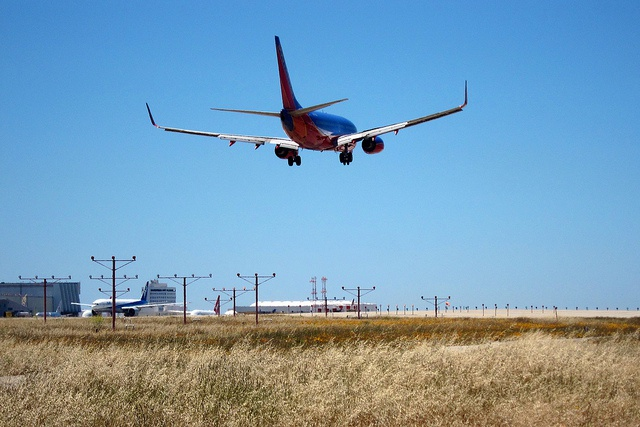Describe the objects in this image and their specific colors. I can see airplane in gray, lightblue, black, maroon, and lightgray tones and airplane in gray, white, black, and navy tones in this image. 